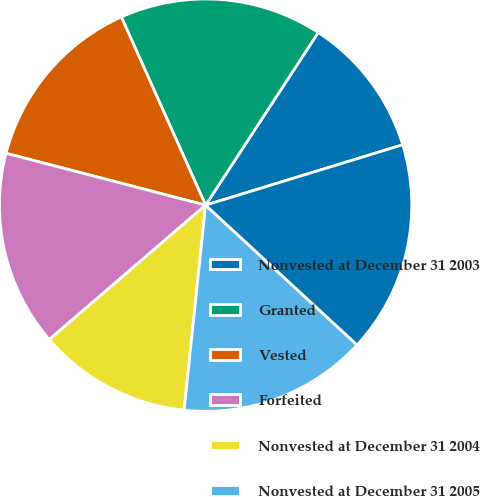<chart> <loc_0><loc_0><loc_500><loc_500><pie_chart><fcel>Nonvested at December 31 2003<fcel>Granted<fcel>Vested<fcel>Forfeited<fcel>Nonvested at December 31 2004<fcel>Nonvested at December 31 2005<fcel>Nonvested at December 31 2006<nl><fcel>11.07%<fcel>15.9%<fcel>14.25%<fcel>15.35%<fcel>12.03%<fcel>14.8%<fcel>16.59%<nl></chart> 